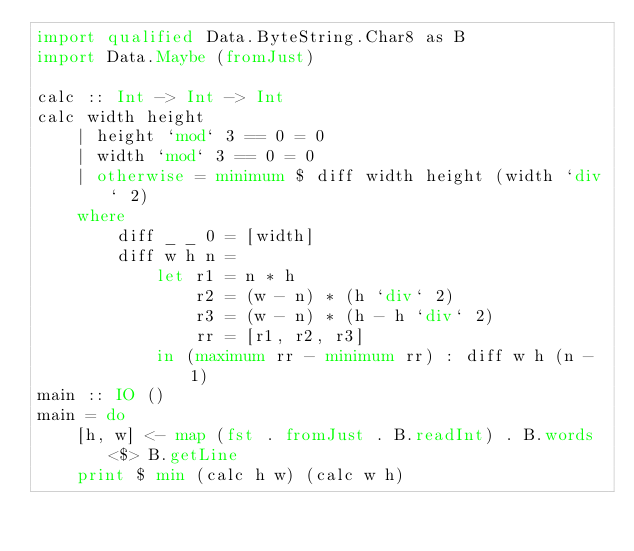Convert code to text. <code><loc_0><loc_0><loc_500><loc_500><_Haskell_>import qualified Data.ByteString.Char8 as B
import Data.Maybe (fromJust)

calc :: Int -> Int -> Int
calc width height
    | height `mod` 3 == 0 = 0
    | width `mod` 3 == 0 = 0
    | otherwise = minimum $ diff width height (width `div` 2)
    where
        diff _ _ 0 = [width]
        diff w h n =
            let r1 = n * h
                r2 = (w - n) * (h `div` 2)
                r3 = (w - n) * (h - h `div` 2)
                rr = [r1, r2, r3]
            in (maximum rr - minimum rr) : diff w h (n - 1)
main :: IO ()
main = do
    [h, w] <- map (fst . fromJust . B.readInt) . B.words <$> B.getLine
    print $ min (calc h w) (calc w h)
</code> 